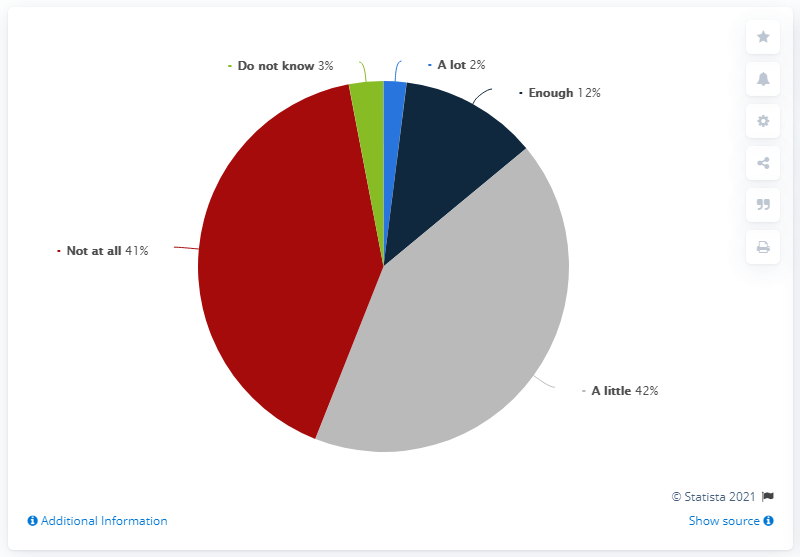Give some essential details in this illustration. 41% of Italian interviewees expressed displeasure with the European Union's attitude towards Italy. The number one attitude in the chart is a little bit. According to the survey, 56% of the respondents expressed appreciation for the intervention. 